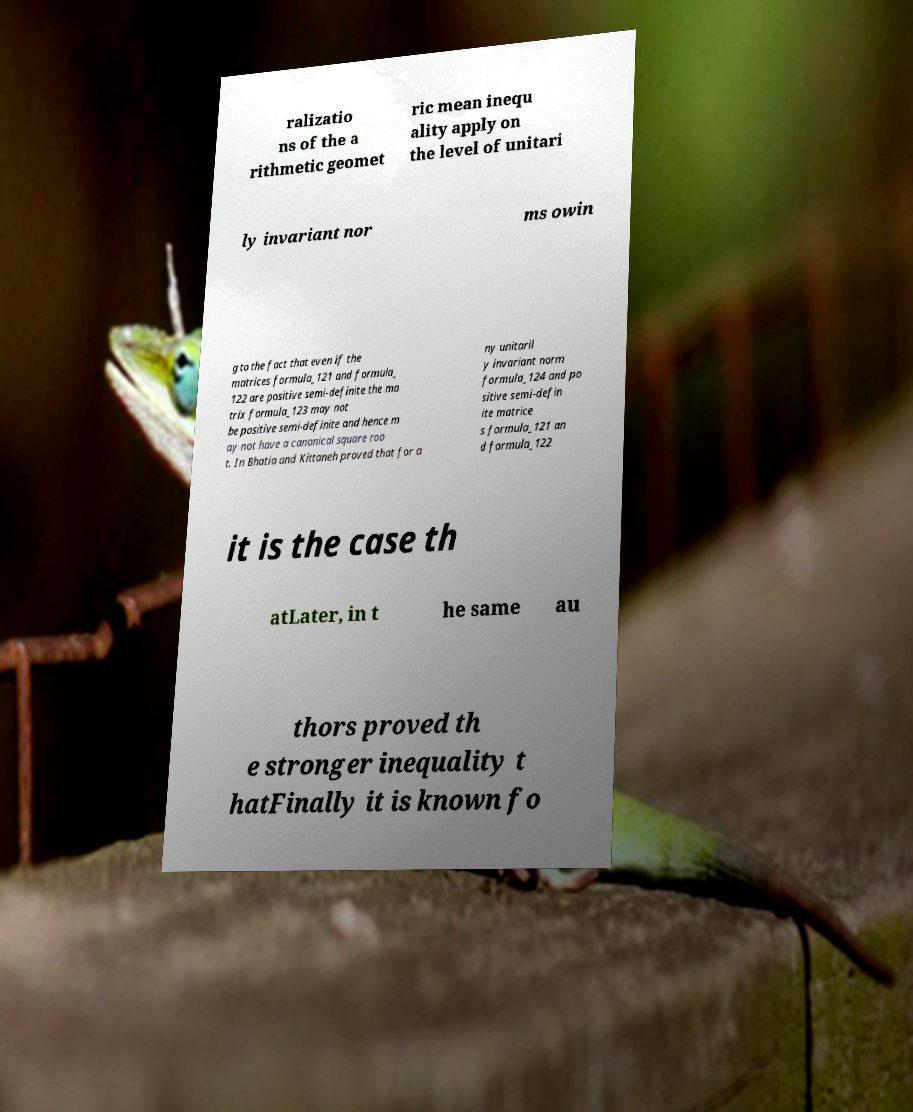There's text embedded in this image that I need extracted. Can you transcribe it verbatim? ralizatio ns of the a rithmetic geomet ric mean inequ ality apply on the level of unitari ly invariant nor ms owin g to the fact that even if the matrices formula_121 and formula_ 122 are positive semi-definite the ma trix formula_123 may not be positive semi-definite and hence m ay not have a canonical square roo t. In Bhatia and Kittaneh proved that for a ny unitaril y invariant norm formula_124 and po sitive semi-defin ite matrice s formula_121 an d formula_122 it is the case th atLater, in t he same au thors proved th e stronger inequality t hatFinally it is known fo 